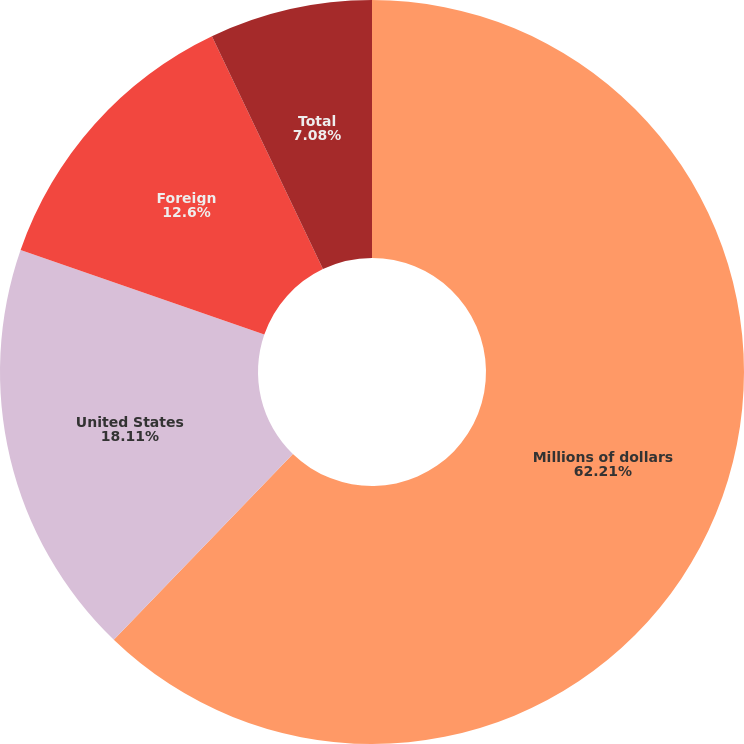Convert chart to OTSL. <chart><loc_0><loc_0><loc_500><loc_500><pie_chart><fcel>Millions of dollars<fcel>United States<fcel>Foreign<fcel>Total<nl><fcel>62.21%<fcel>18.11%<fcel>12.6%<fcel>7.08%<nl></chart> 